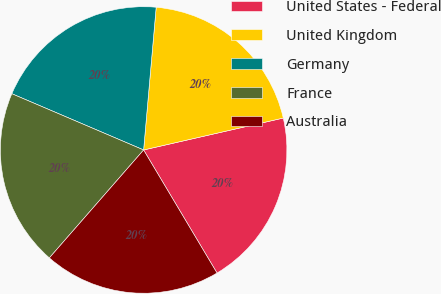Convert chart. <chart><loc_0><loc_0><loc_500><loc_500><pie_chart><fcel>United States - Federal<fcel>United Kingdom<fcel>Germany<fcel>France<fcel>Australia<nl><fcel>20.02%<fcel>20.03%<fcel>19.98%<fcel>20.0%<fcel>19.99%<nl></chart> 